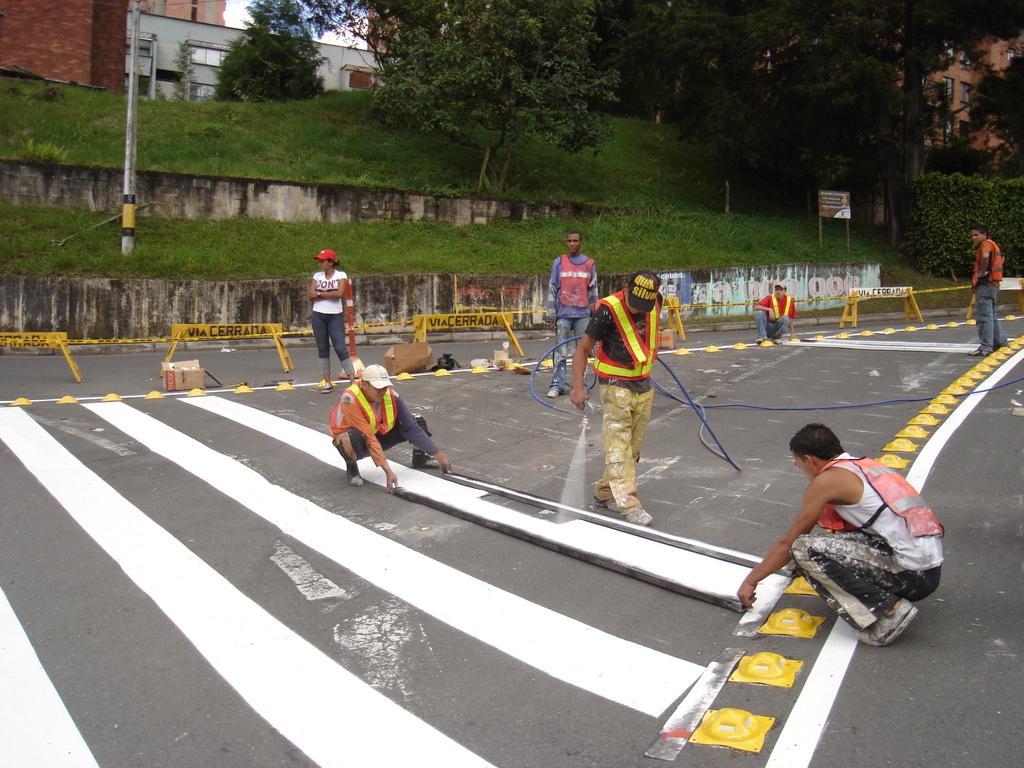Describe this image in one or two sentences. In this image we can see few persons are sitting and holding sticks and there is another person holding pipe. And there are a few people standing. There is a white paint on the road. And there are barricades, trees, board, buildings and pole. 